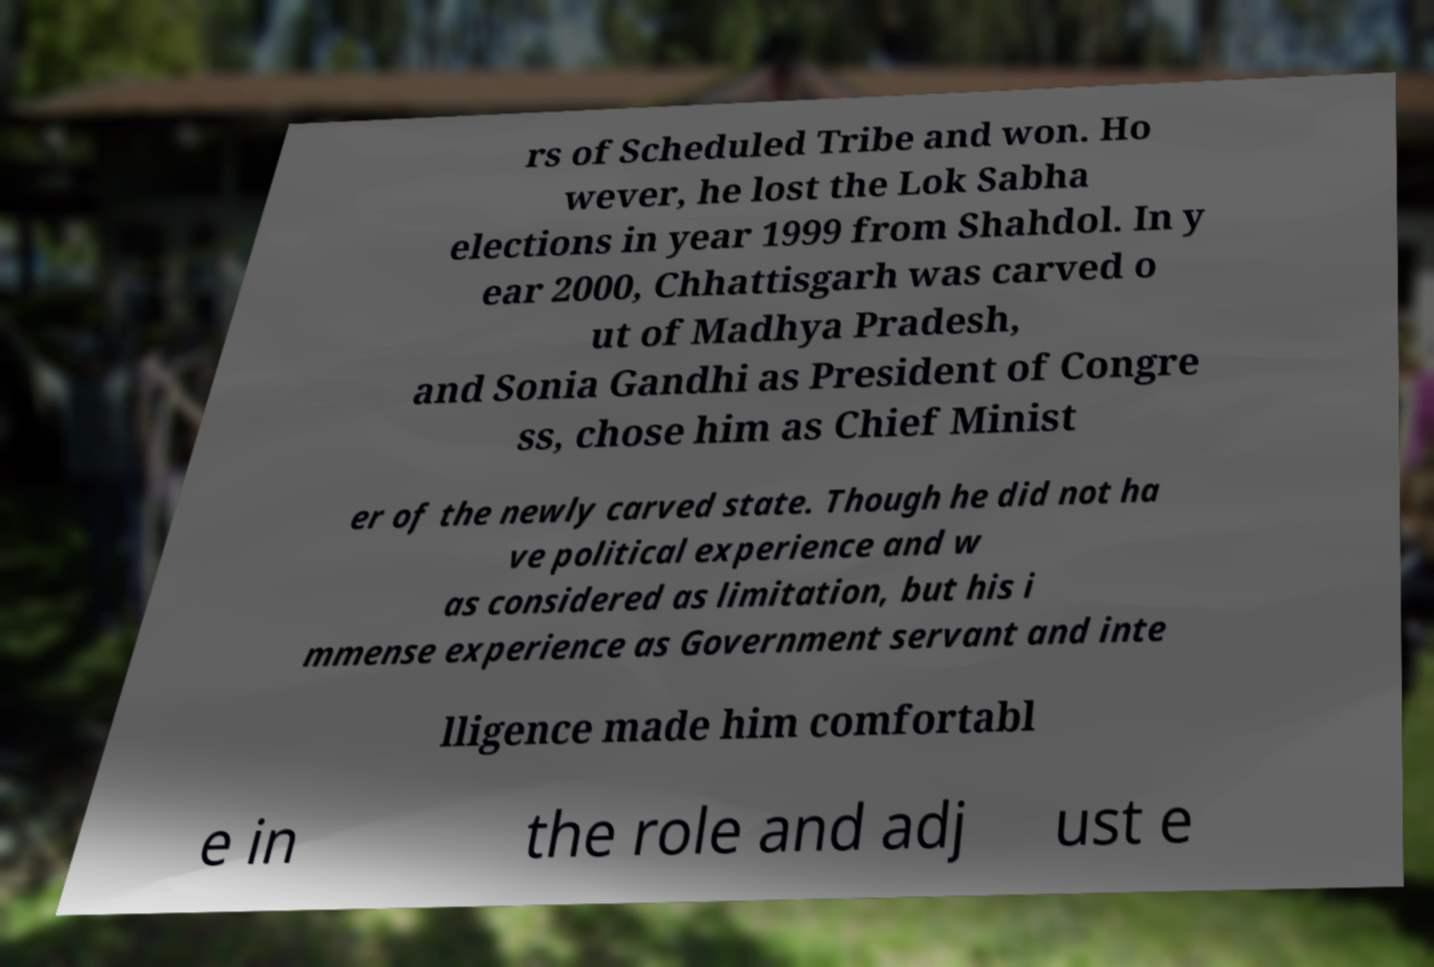Could you extract and type out the text from this image? rs of Scheduled Tribe and won. Ho wever, he lost the Lok Sabha elections in year 1999 from Shahdol. In y ear 2000, Chhattisgarh was carved o ut of Madhya Pradesh, and Sonia Gandhi as President of Congre ss, chose him as Chief Minist er of the newly carved state. Though he did not ha ve political experience and w as considered as limitation, but his i mmense experience as Government servant and inte lligence made him comfortabl e in the role and adj ust e 